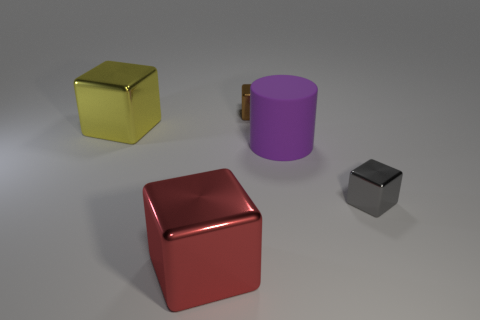There is another tiny thing that is the same shape as the gray shiny thing; what is its color?
Provide a succinct answer. Brown. What size is the brown cube?
Provide a short and direct response. Small. There is a matte object that is the same size as the red metal block; what color is it?
Give a very brief answer. Purple. What material is the cylinder?
Your answer should be very brief. Rubber. What number of gray metallic spheres are there?
Offer a terse response. 0. What number of other things are there of the same size as the yellow shiny block?
Make the answer very short. 2. There is a large block right of the yellow shiny thing; what color is it?
Offer a terse response. Red. Do the brown block that is on the left side of the small gray metal object and the big cylinder have the same material?
Provide a succinct answer. No. What number of big things are on the right side of the brown shiny object and in front of the matte cylinder?
Offer a terse response. 0. There is a tiny shiny thing in front of the small metallic thing that is on the left side of the tiny metal object that is to the right of the brown cube; what color is it?
Your answer should be very brief. Gray. 